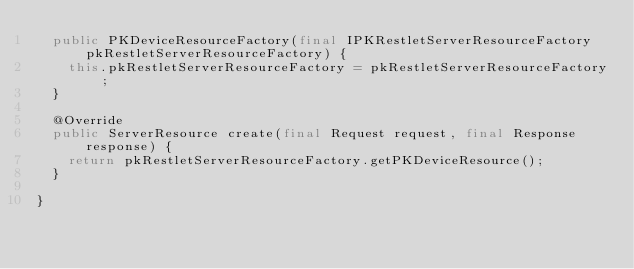Convert code to text. <code><loc_0><loc_0><loc_500><loc_500><_Java_>	public PKDeviceResourceFactory(final IPKRestletServerResourceFactory pkRestletServerResourceFactory) {
		this.pkRestletServerResourceFactory = pkRestletServerResourceFactory;
	}

	@Override
	public ServerResource create(final Request request, final Response response) {
		return pkRestletServerResourceFactory.getPKDeviceResource();
	}

}
</code> 